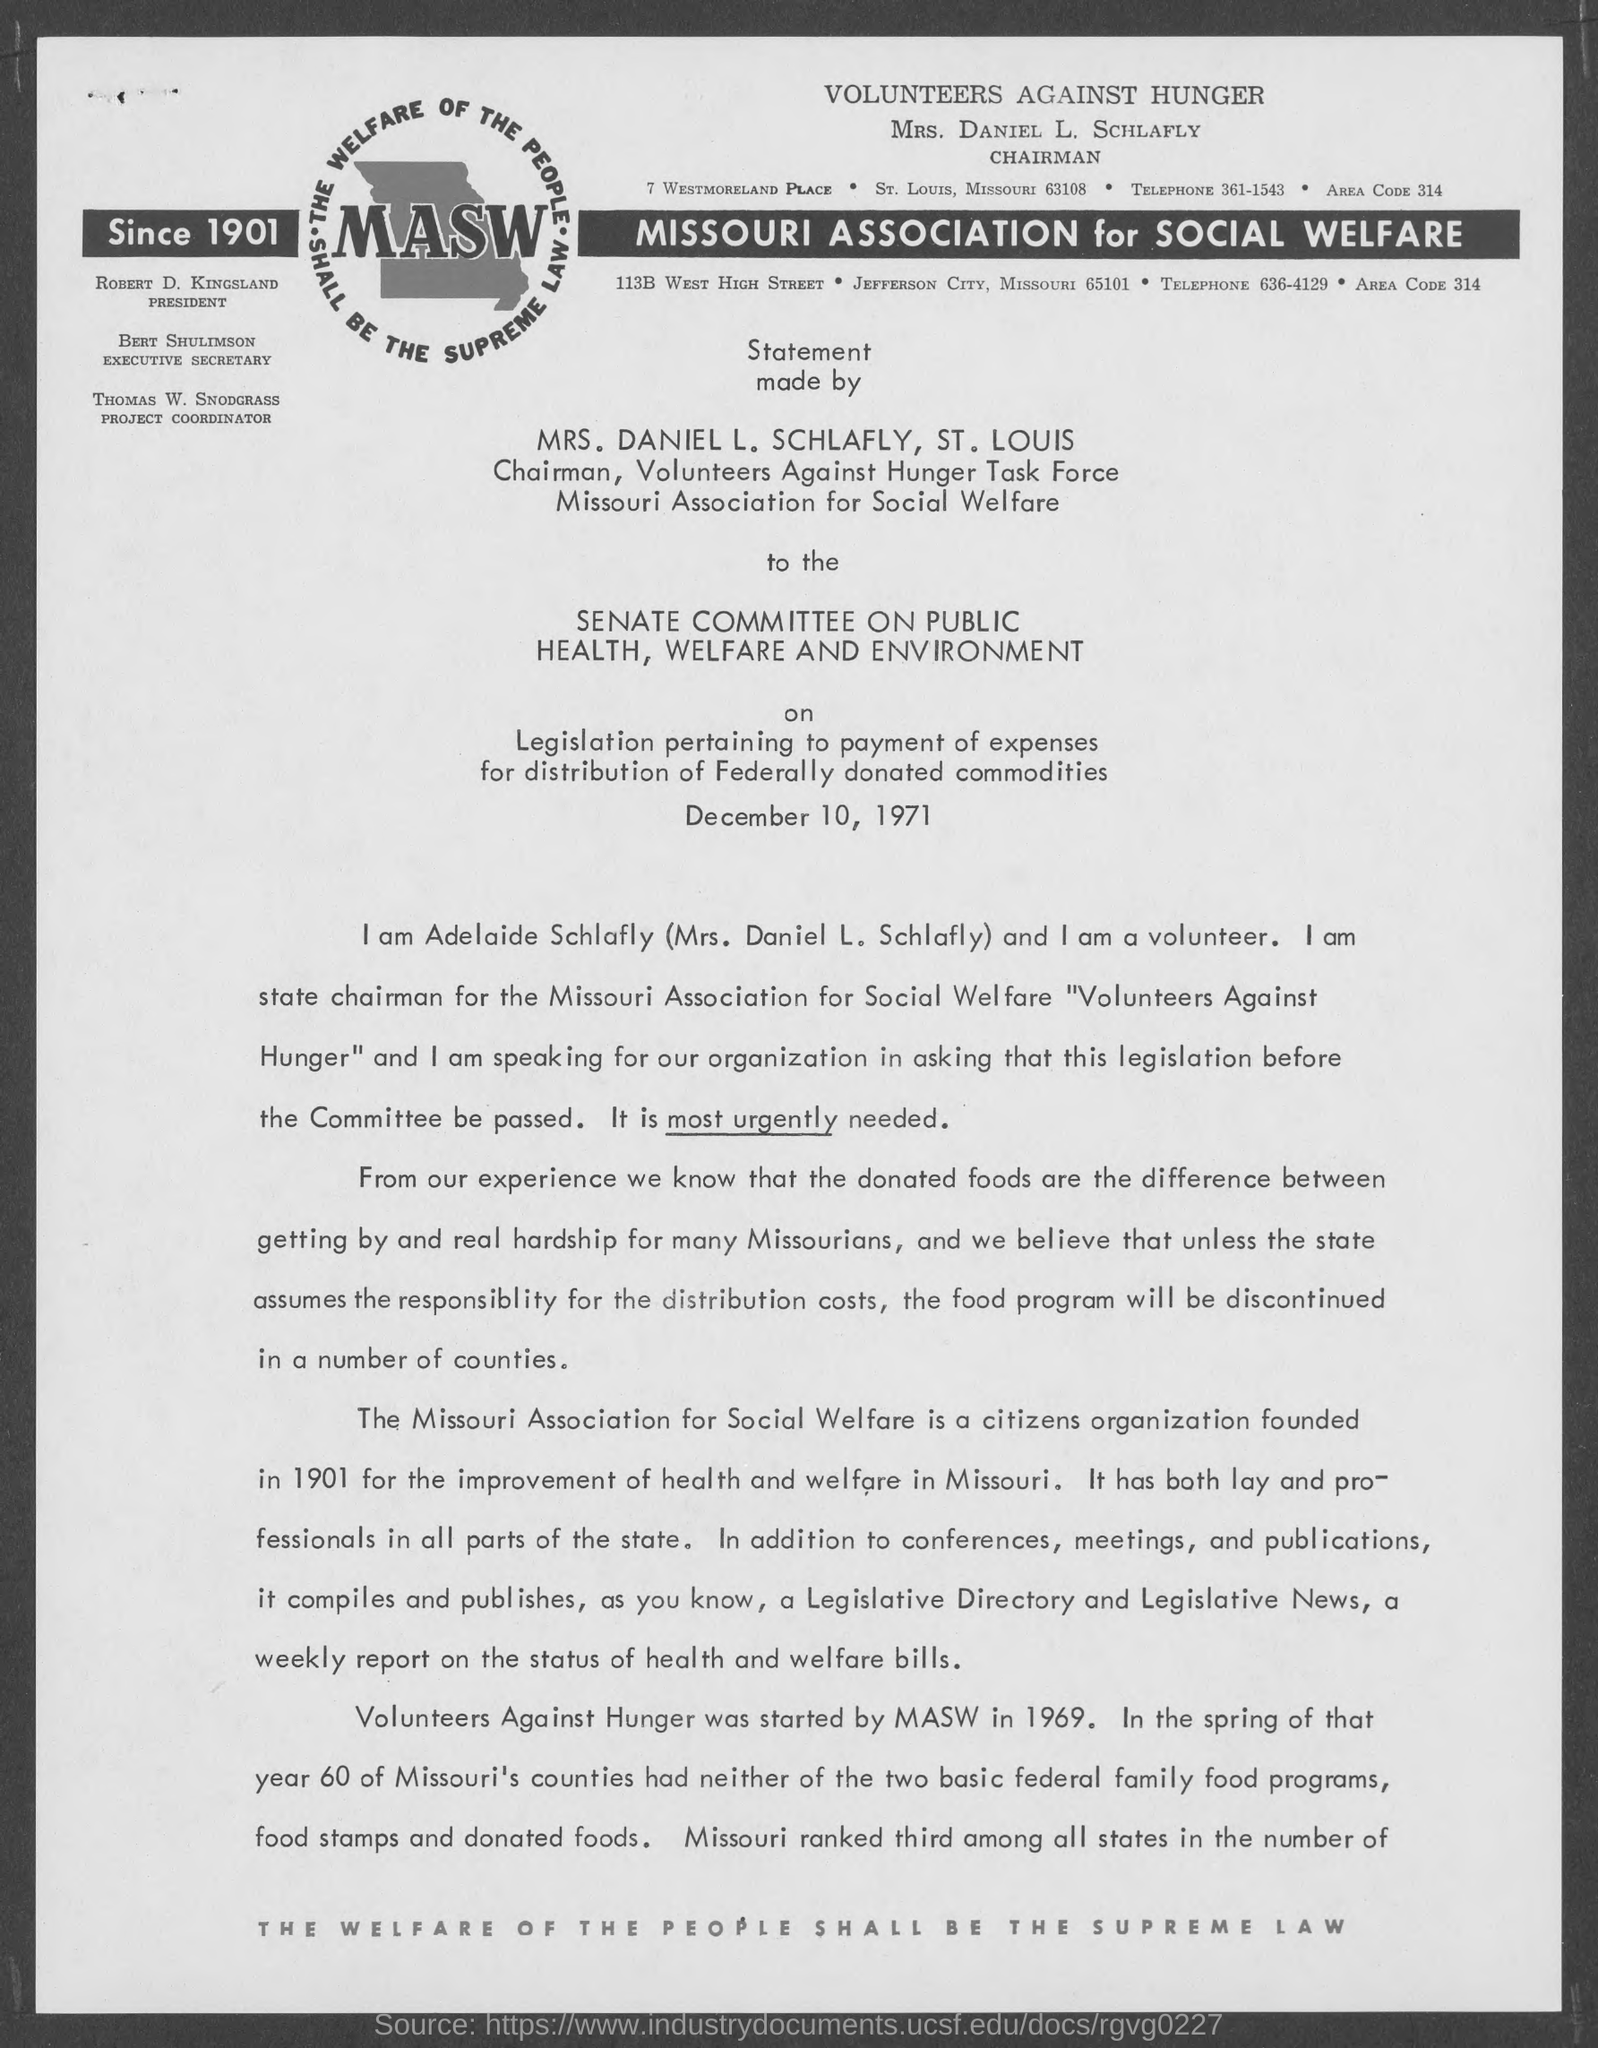What  is the heading mentioned in the given page ?
Offer a terse response. Volunteers Against Hunger. What is the designation of robert d. kingsland as mentioned in the given page ?
Offer a very short reply. President. What is the designation of bert shulimson as mentioned in the given page ?
Make the answer very short. Executive secretary. What is the name of the project coordinator mentioned in the given page ?
Your answer should be compact. Thomas W. Snodgrass. What is the area code mentioned in the given form ?
Offer a terse response. 314. What is the telephone no. mentioned in the given page ?
Keep it short and to the point. 361-1543. What is the full form of masw as mentioned in the given form ?
Give a very brief answer. Missouri Association for social welfare. 